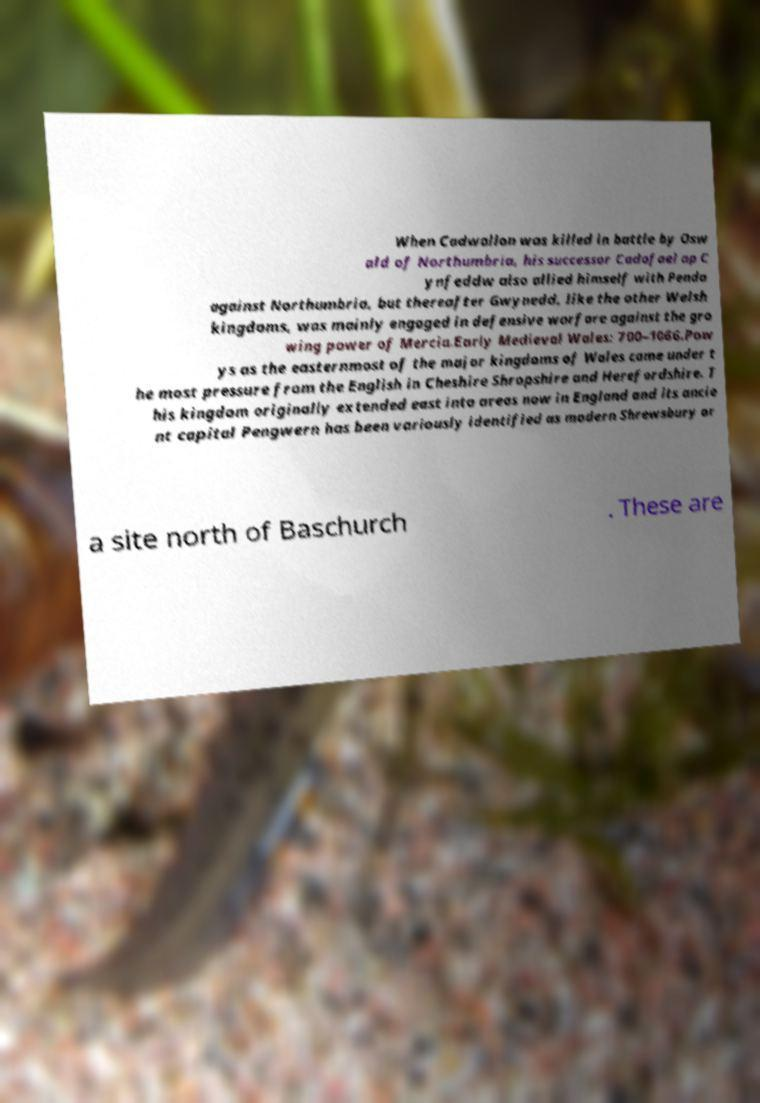Could you extract and type out the text from this image? When Cadwallon was killed in battle by Osw ald of Northumbria, his successor Cadafael ap C ynfeddw also allied himself with Penda against Northumbria, but thereafter Gwynedd, like the other Welsh kingdoms, was mainly engaged in defensive warfare against the gro wing power of Mercia.Early Medieval Wales: 700–1066.Pow ys as the easternmost of the major kingdoms of Wales came under t he most pressure from the English in Cheshire Shropshire and Herefordshire. T his kingdom originally extended east into areas now in England and its ancie nt capital Pengwern has been variously identified as modern Shrewsbury or a site north of Baschurch . These are 